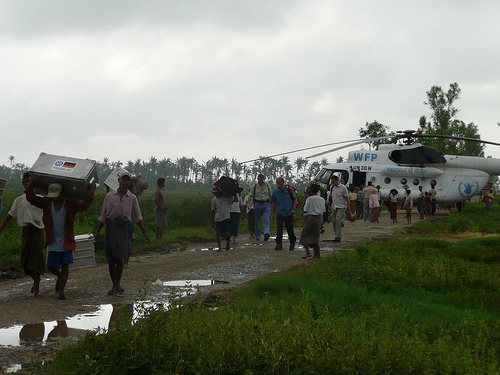<image>
Is there a man to the left of the man? Yes. From this viewpoint, the man is positioned to the left side relative to the man. 